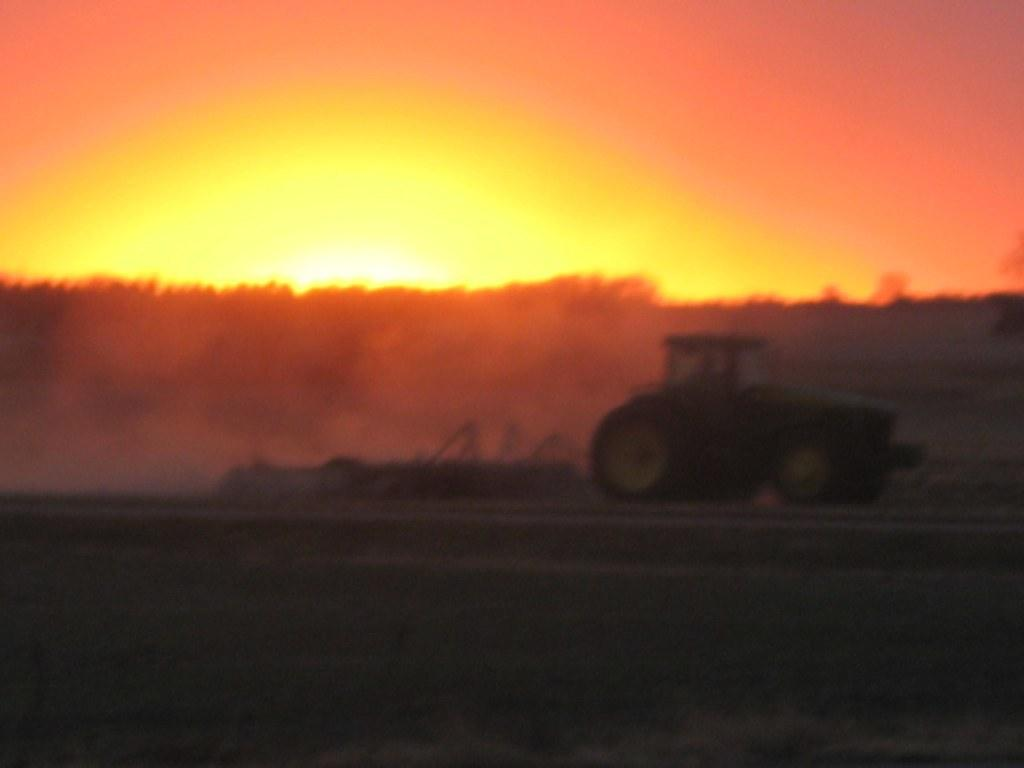What type of land is shown in the image? There is a land in the image. What can be seen on the land? There is a tractor on the land. What is visible in the background of the image? There are trees and the sky visible in the background of the image. How many partners are working together on the plantation in the image? There is no plantation or partners present in the image; it features a tractor on a piece of land with trees and the sky in the background. 